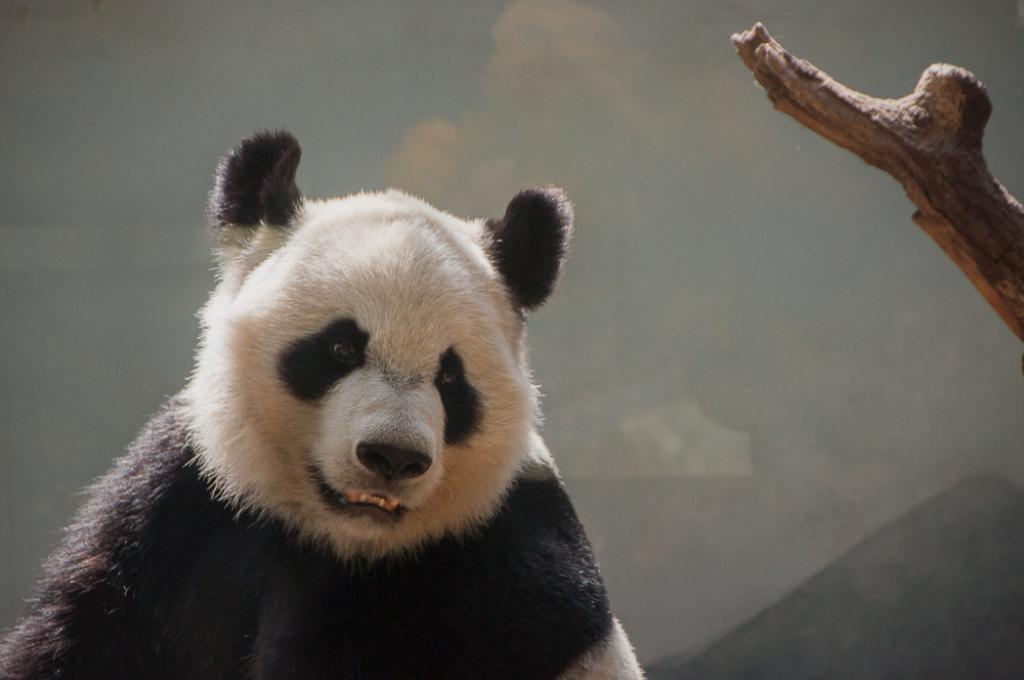What animal is present in the image? There is a bear in the image. What color scheme is used for the bear? The bear is in black and white color. What can be seen on the right side of the image? There is a branch of a tree on the right side of the image. Is there a squirrel attending a meeting in the image? There is no squirrel or meeting present in the image. 